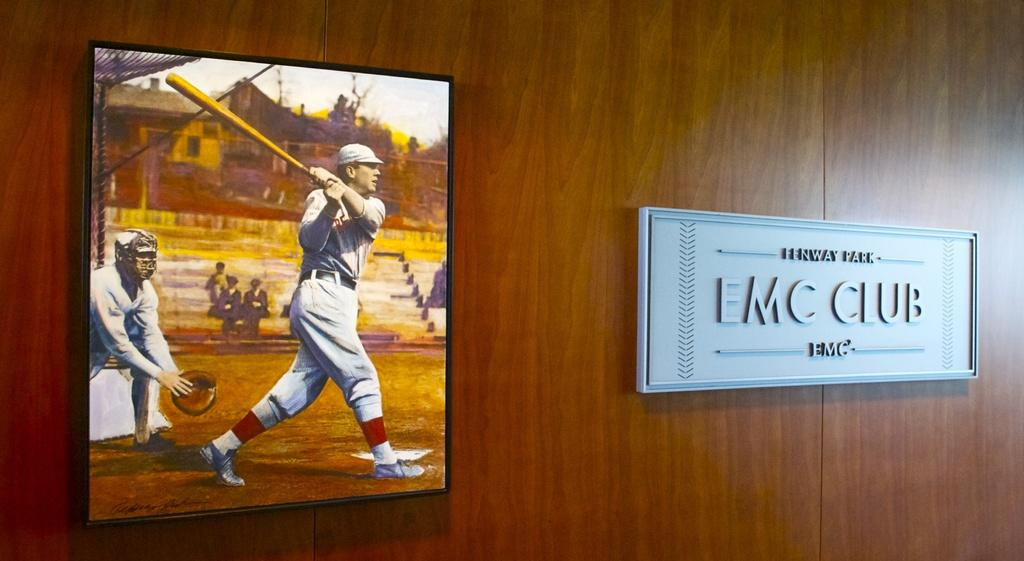<image>
Present a compact description of the photo's key features. One illustrated poster of a baseball player hitting a ball next to a Fenway Park EMC CLUB plaque on a wooden wall. 